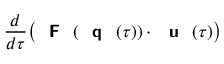Convert formula to latex. <formula><loc_0><loc_0><loc_500><loc_500>\frac { d } { d \tau } \left ( { F } ( { q } ( \tau ) ) \cdot { u } ( \tau ) \right )</formula> 